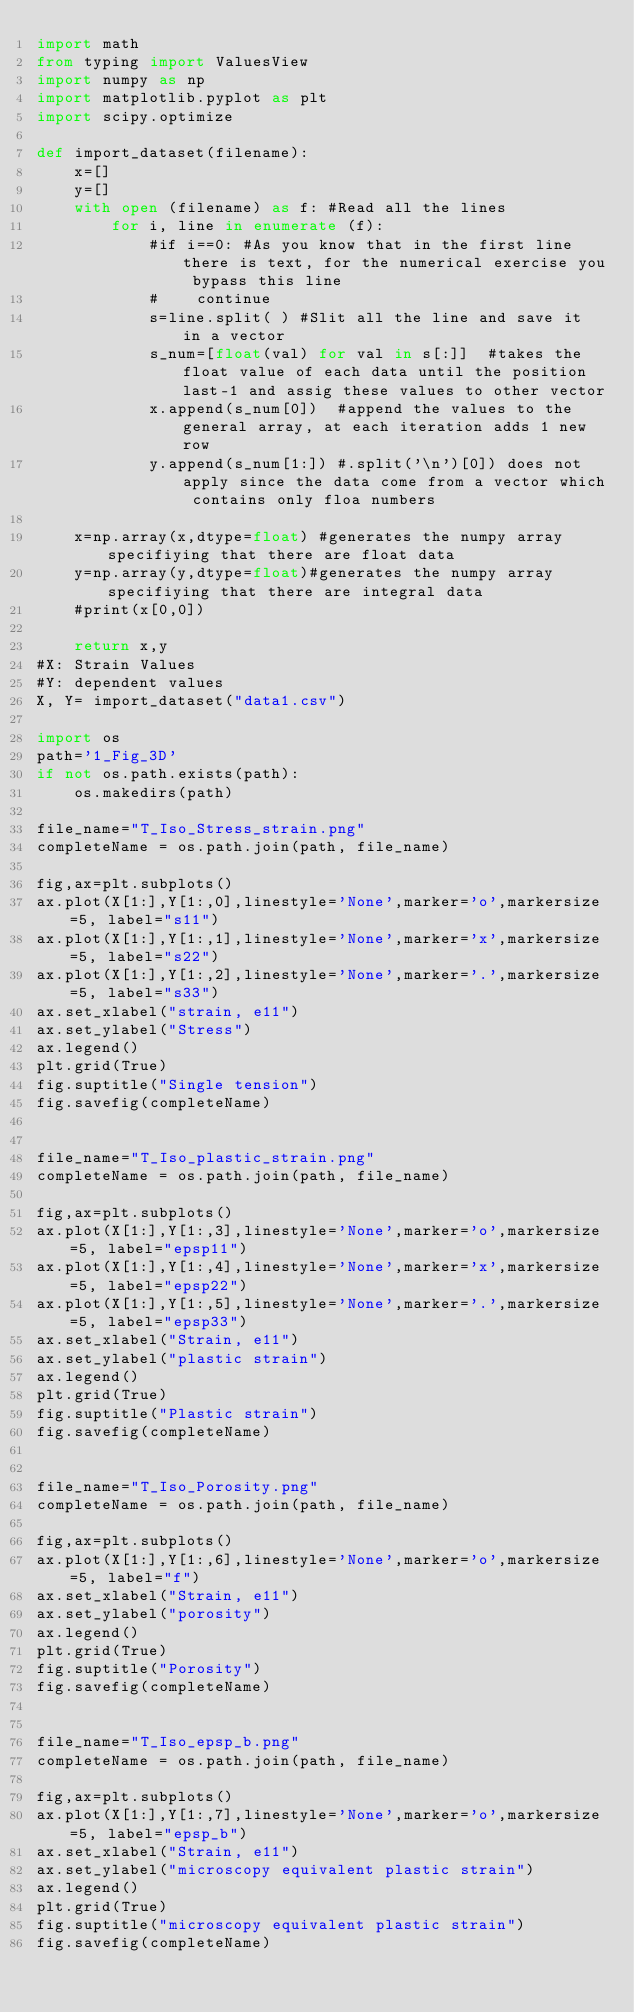<code> <loc_0><loc_0><loc_500><loc_500><_Python_>import math
from typing import ValuesView
import numpy as np
import matplotlib.pyplot as plt
import scipy.optimize

def import_dataset(filename):
    x=[]
    y=[]
    with open (filename) as f: #Read all the lines
        for i, line in enumerate (f): 
            #if i==0: #As you know that in the first line there is text, for the numerical exercise you bypass this line
            #    continue
            s=line.split( ) #Slit all the line and save it in a vector
            s_num=[float(val) for val in s[:]]  #takes the float value of each data until the position last-1 and assig these values to other vector 
            x.append(s_num[0])  #append the values to the general array, at each iteration adds 1 new row
            y.append(s_num[1:]) #.split('\n')[0]) does not apply since the data come from a vector which contains only floa numbers
            
    x=np.array(x,dtype=float) #generates the numpy array specifiying that there are float data
    y=np.array(y,dtype=float)#generates the numpy array specifiying that there are integral data
    #print(x[0,0])
    
    return x,y
#X: Strain Values
#Y: dependent values
X, Y= import_dataset("data1.csv")

import os
path='1_Fig_3D'
if not os.path.exists(path):
    os.makedirs(path)

file_name="T_Iso_Stress_strain.png"
completeName = os.path.join(path, file_name)

fig,ax=plt.subplots()
ax.plot(X[1:],Y[1:,0],linestyle='None',marker='o',markersize=5, label="s11")
ax.plot(X[1:],Y[1:,1],linestyle='None',marker='x',markersize=5, label="s22") 
ax.plot(X[1:],Y[1:,2],linestyle='None',marker='.',markersize=5, label="s33")
ax.set_xlabel("strain, e11")
ax.set_ylabel("Stress")
ax.legend()
plt.grid(True)     
fig.suptitle("Single tension")
fig.savefig(completeName)


file_name="T_Iso_plastic_strain.png"
completeName = os.path.join(path, file_name)

fig,ax=plt.subplots()
ax.plot(X[1:],Y[1:,3],linestyle='None',marker='o',markersize=5, label="epsp11")
ax.plot(X[1:],Y[1:,4],linestyle='None',marker='x',markersize=5, label="epsp22") 
ax.plot(X[1:],Y[1:,5],linestyle='None',marker='.',markersize=5, label="epsp33")
ax.set_xlabel("Strain, e11")
ax.set_ylabel("plastic strain")
ax.legend()
plt.grid(True)  
fig.suptitle("Plastic strain")
fig.savefig(completeName)


file_name="T_Iso_Porosity.png"
completeName = os.path.join(path, file_name)

fig,ax=plt.subplots()
ax.plot(X[1:],Y[1:,6],linestyle='None',marker='o',markersize=5, label="f")
ax.set_xlabel("Strain, e11")
ax.set_ylabel("porosity")
ax.legend()
plt.grid(True)  
fig.suptitle("Porosity")
fig.savefig(completeName)


file_name="T_Iso_epsp_b.png"
completeName = os.path.join(path, file_name)

fig,ax=plt.subplots()
ax.plot(X[1:],Y[1:,7],linestyle='None',marker='o',markersize=5, label="epsp_b")
ax.set_xlabel("Strain, e11")
ax.set_ylabel("microscopy equivalent plastic strain")
ax.legend()   
plt.grid(True)  
fig.suptitle("microscopy equivalent plastic strain")
fig.savefig(completeName)</code> 